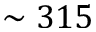Convert formula to latex. <formula><loc_0><loc_0><loc_500><loc_500>\sim 3 1 5</formula> 